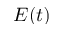<formula> <loc_0><loc_0><loc_500><loc_500>E ( t )</formula> 